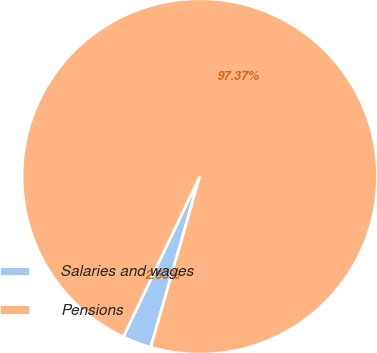Convert chart. <chart><loc_0><loc_0><loc_500><loc_500><pie_chart><fcel>Salaries and wages<fcel>Pensions<nl><fcel>2.63%<fcel>97.37%<nl></chart> 